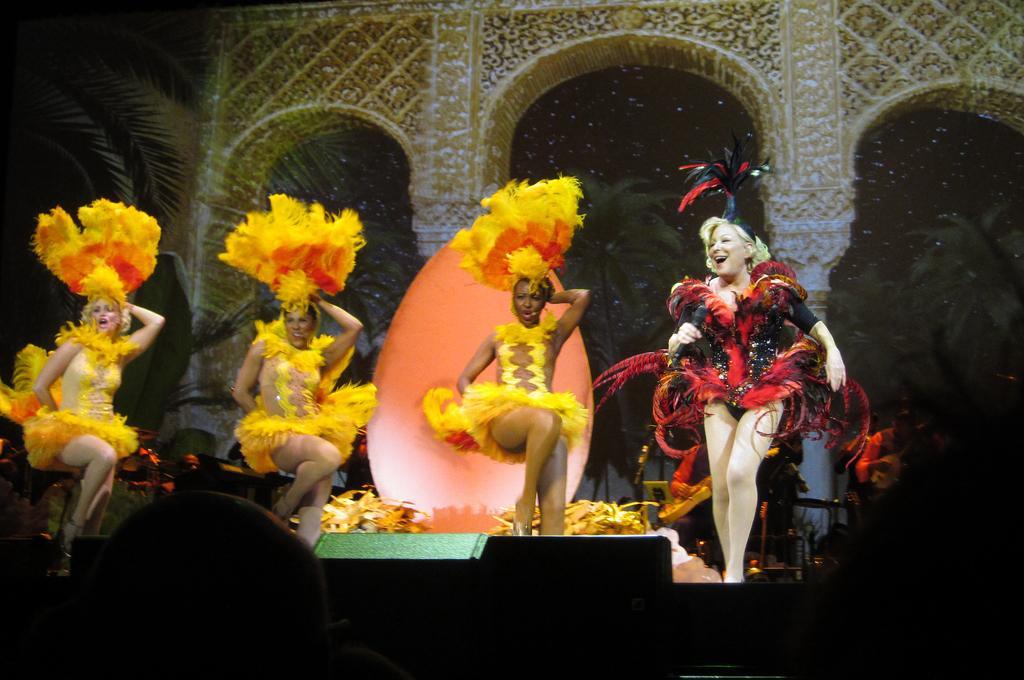In one or two sentences, can you explain what this image depicts? On the left side, there are three women in yellow color dresses, dancing on a stage. On the right side, there is a woman in red and black color combination dress, smiling, dancing and holding a mic with a hand. In the background, there are arches. And the background is dark in color. 